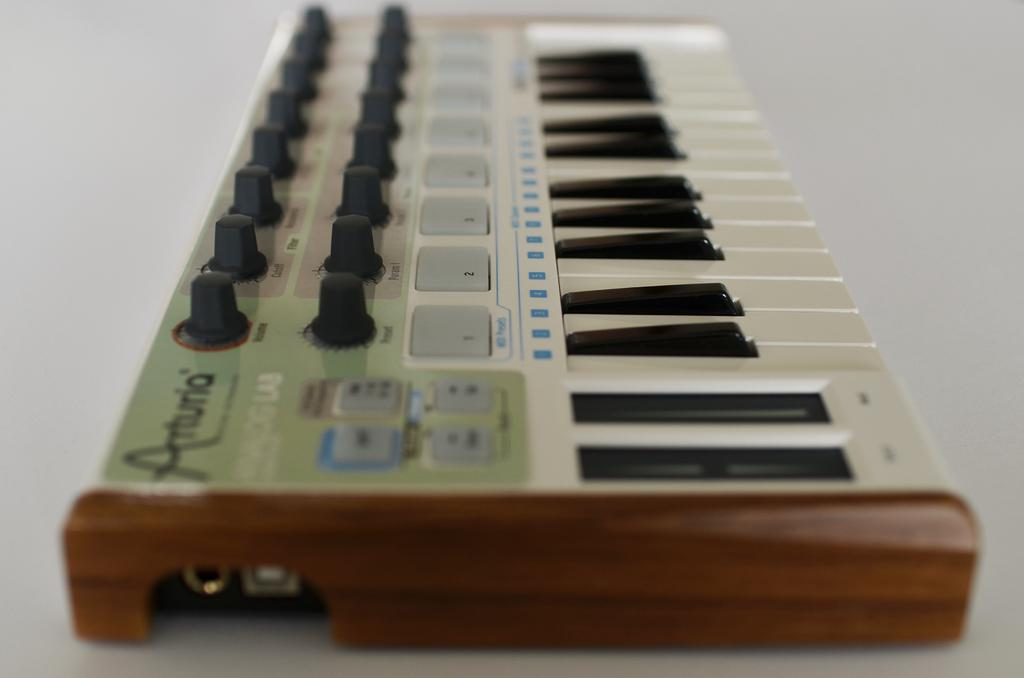What is the main object in the image? There is a piano in the image. What type of birds can be seen flying around the piano in the image? There are no birds present in the image; it only features a piano. 